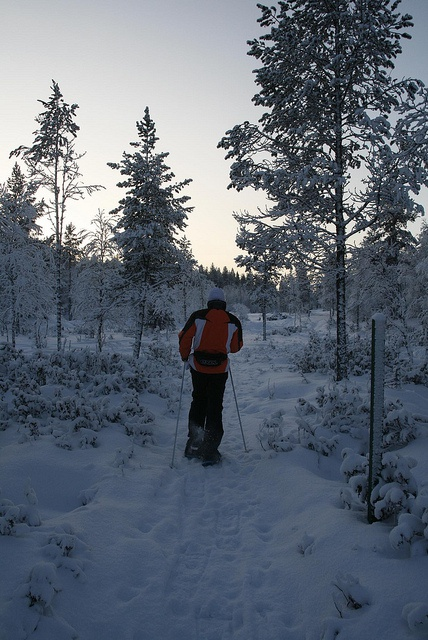Describe the objects in this image and their specific colors. I can see people in lightgray, black, gray, and darkblue tones and skis in lightgray, black, navy, darkblue, and blue tones in this image. 